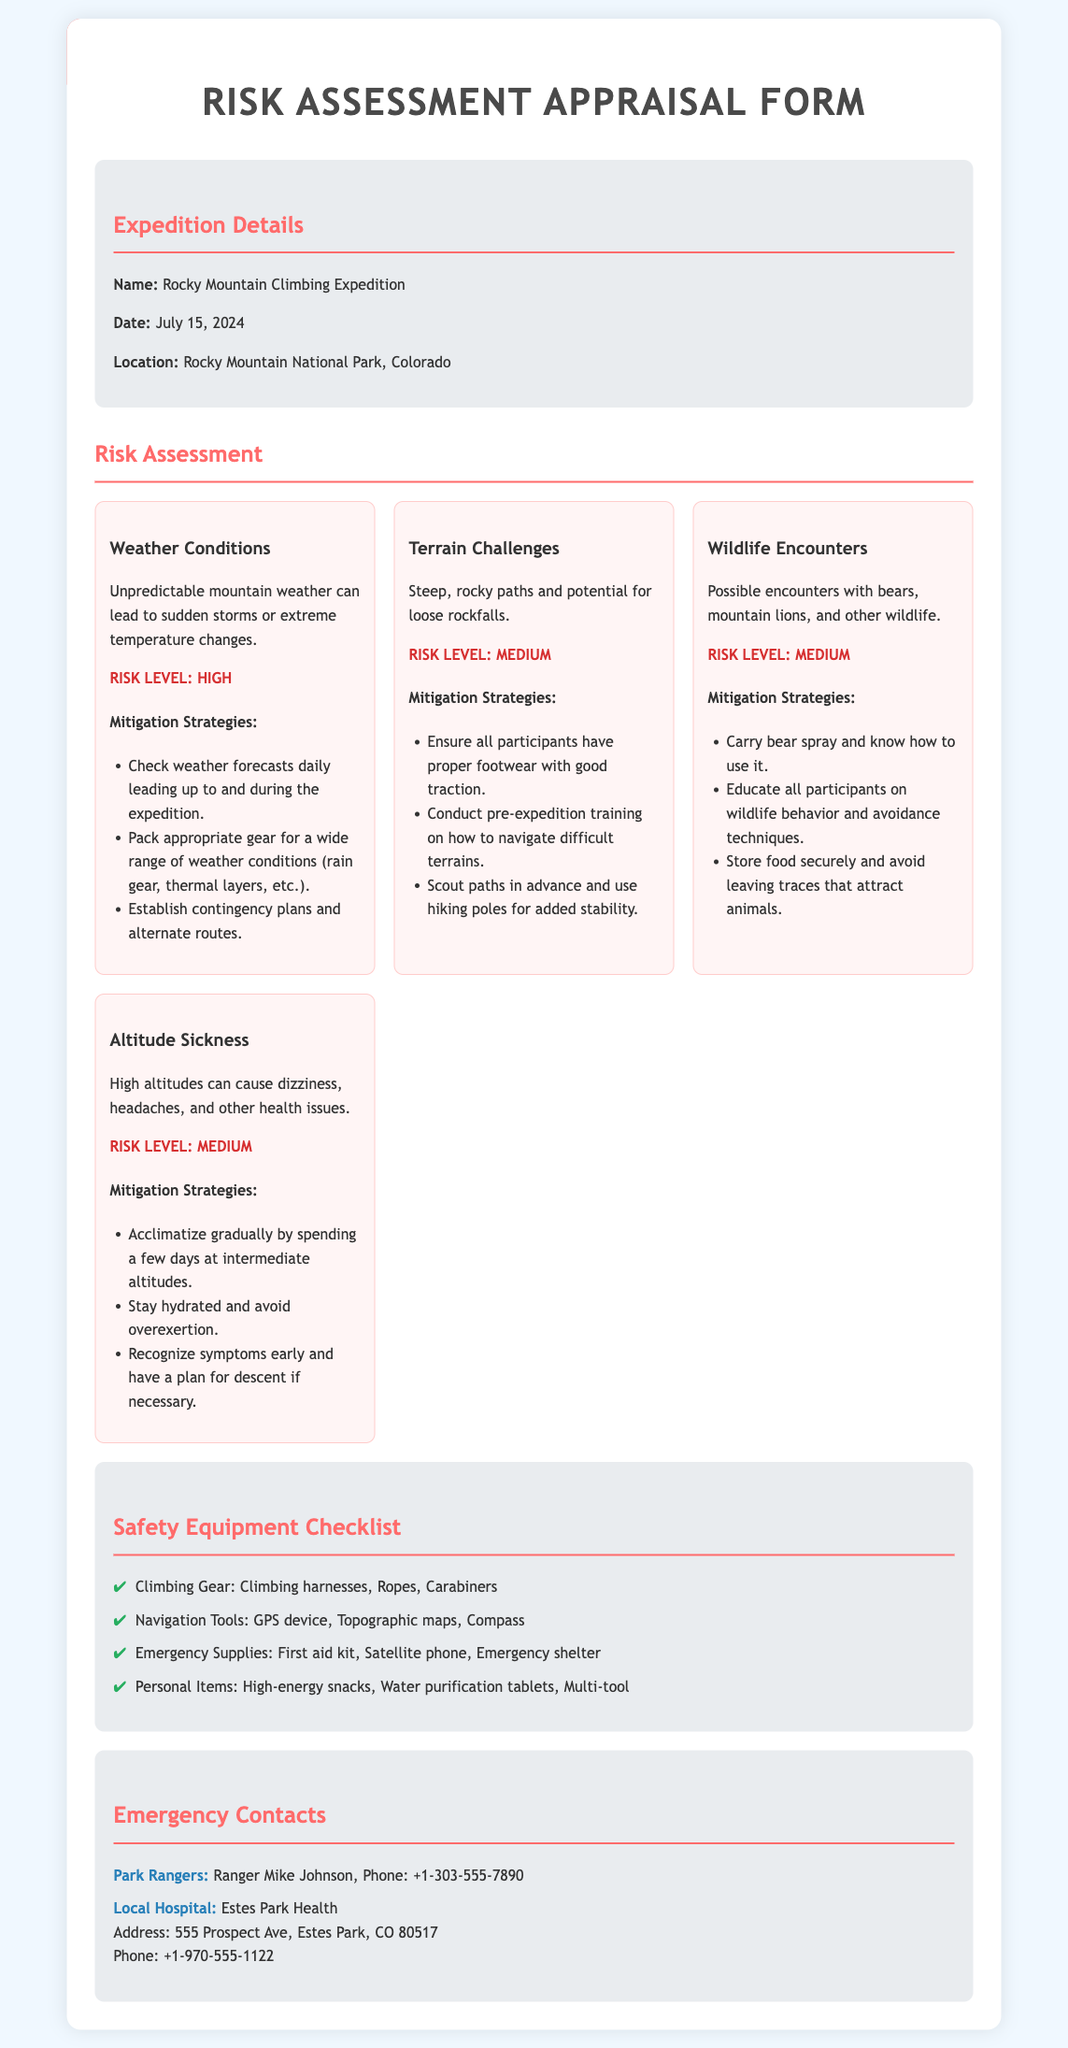What is the name of the expedition? The name of the expedition is mentioned in the expedition details section.
Answer: Rocky Mountain Climbing Expedition What is the date of the expedition? The date is specified in the expedition details section.
Answer: July 15, 2024 What is the location of the expedition? The location is provided in the expedition details section.
Answer: Rocky Mountain National Park, Colorado What is the risk level associated with weather conditions? The risk level for weather conditions can be found in the risk assessment section.
Answer: High What equipment is needed for climbing? This information is found in the safety equipment checklist section.
Answer: Climbing Gear: Climbing harnesses, Ropes, Carabiners What does the mitigation strategy for altitude sickness suggest for hydration? This part is included in the mitigation strategies for altitude sickness in the risk assessment section.
Answer: Stay hydrated What must participants carry to handle wildlife encounters? This requirement is listed in the mitigation strategies for wildlife encounters.
Answer: Bear spray How can participants prepare for terrain challenges? The suggested preparation can be found in the mitigation strategies for terrain challenges.
Answer: Conduct pre-expedition training Who is the emergency contact for park rangers? The emergency contact details are given in the emergency contacts section.
Answer: Ranger Mike Johnson 